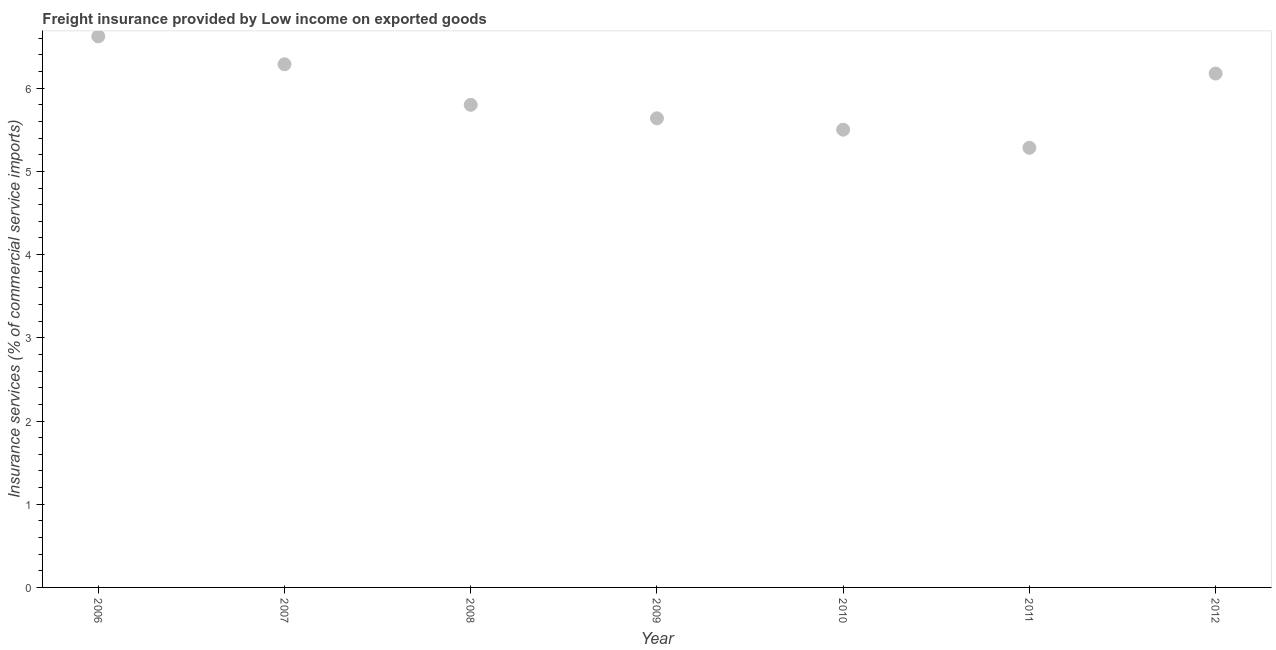What is the freight insurance in 2007?
Your answer should be compact. 6.29. Across all years, what is the maximum freight insurance?
Offer a very short reply. 6.62. Across all years, what is the minimum freight insurance?
Ensure brevity in your answer.  5.28. In which year was the freight insurance maximum?
Provide a succinct answer. 2006. In which year was the freight insurance minimum?
Your response must be concise. 2011. What is the sum of the freight insurance?
Your answer should be very brief. 41.31. What is the difference between the freight insurance in 2007 and 2012?
Give a very brief answer. 0.11. What is the average freight insurance per year?
Ensure brevity in your answer.  5.9. What is the median freight insurance?
Offer a very short reply. 5.8. In how many years, is the freight insurance greater than 5.4 %?
Your response must be concise. 6. Do a majority of the years between 2006 and 2007 (inclusive) have freight insurance greater than 2.8 %?
Provide a short and direct response. Yes. What is the ratio of the freight insurance in 2009 to that in 2011?
Offer a very short reply. 1.07. Is the freight insurance in 2006 less than that in 2012?
Offer a terse response. No. What is the difference between the highest and the second highest freight insurance?
Offer a terse response. 0.33. What is the difference between the highest and the lowest freight insurance?
Provide a succinct answer. 1.34. In how many years, is the freight insurance greater than the average freight insurance taken over all years?
Offer a terse response. 3. How many dotlines are there?
Your answer should be very brief. 1. What is the difference between two consecutive major ticks on the Y-axis?
Make the answer very short. 1. Are the values on the major ticks of Y-axis written in scientific E-notation?
Your response must be concise. No. Does the graph contain any zero values?
Give a very brief answer. No. What is the title of the graph?
Offer a very short reply. Freight insurance provided by Low income on exported goods . What is the label or title of the X-axis?
Give a very brief answer. Year. What is the label or title of the Y-axis?
Your response must be concise. Insurance services (% of commercial service imports). What is the Insurance services (% of commercial service imports) in 2006?
Give a very brief answer. 6.62. What is the Insurance services (% of commercial service imports) in 2007?
Ensure brevity in your answer.  6.29. What is the Insurance services (% of commercial service imports) in 2008?
Offer a terse response. 5.8. What is the Insurance services (% of commercial service imports) in 2009?
Offer a very short reply. 5.64. What is the Insurance services (% of commercial service imports) in 2010?
Your response must be concise. 5.5. What is the Insurance services (% of commercial service imports) in 2011?
Your answer should be very brief. 5.28. What is the Insurance services (% of commercial service imports) in 2012?
Keep it short and to the point. 6.18. What is the difference between the Insurance services (% of commercial service imports) in 2006 and 2007?
Offer a terse response. 0.33. What is the difference between the Insurance services (% of commercial service imports) in 2006 and 2008?
Your answer should be very brief. 0.82. What is the difference between the Insurance services (% of commercial service imports) in 2006 and 2009?
Your answer should be very brief. 0.98. What is the difference between the Insurance services (% of commercial service imports) in 2006 and 2010?
Offer a very short reply. 1.12. What is the difference between the Insurance services (% of commercial service imports) in 2006 and 2011?
Provide a short and direct response. 1.34. What is the difference between the Insurance services (% of commercial service imports) in 2006 and 2012?
Provide a succinct answer. 0.45. What is the difference between the Insurance services (% of commercial service imports) in 2007 and 2008?
Keep it short and to the point. 0.49. What is the difference between the Insurance services (% of commercial service imports) in 2007 and 2009?
Provide a short and direct response. 0.65. What is the difference between the Insurance services (% of commercial service imports) in 2007 and 2010?
Offer a terse response. 0.79. What is the difference between the Insurance services (% of commercial service imports) in 2007 and 2011?
Offer a terse response. 1. What is the difference between the Insurance services (% of commercial service imports) in 2007 and 2012?
Your answer should be very brief. 0.11. What is the difference between the Insurance services (% of commercial service imports) in 2008 and 2009?
Offer a terse response. 0.16. What is the difference between the Insurance services (% of commercial service imports) in 2008 and 2010?
Make the answer very short. 0.3. What is the difference between the Insurance services (% of commercial service imports) in 2008 and 2011?
Your response must be concise. 0.52. What is the difference between the Insurance services (% of commercial service imports) in 2008 and 2012?
Make the answer very short. -0.38. What is the difference between the Insurance services (% of commercial service imports) in 2009 and 2010?
Ensure brevity in your answer.  0.14. What is the difference between the Insurance services (% of commercial service imports) in 2009 and 2011?
Make the answer very short. 0.35. What is the difference between the Insurance services (% of commercial service imports) in 2009 and 2012?
Ensure brevity in your answer.  -0.54. What is the difference between the Insurance services (% of commercial service imports) in 2010 and 2011?
Offer a terse response. 0.22. What is the difference between the Insurance services (% of commercial service imports) in 2010 and 2012?
Your answer should be compact. -0.67. What is the difference between the Insurance services (% of commercial service imports) in 2011 and 2012?
Provide a short and direct response. -0.89. What is the ratio of the Insurance services (% of commercial service imports) in 2006 to that in 2007?
Keep it short and to the point. 1.05. What is the ratio of the Insurance services (% of commercial service imports) in 2006 to that in 2008?
Offer a very short reply. 1.14. What is the ratio of the Insurance services (% of commercial service imports) in 2006 to that in 2009?
Offer a terse response. 1.18. What is the ratio of the Insurance services (% of commercial service imports) in 2006 to that in 2010?
Make the answer very short. 1.2. What is the ratio of the Insurance services (% of commercial service imports) in 2006 to that in 2011?
Make the answer very short. 1.25. What is the ratio of the Insurance services (% of commercial service imports) in 2006 to that in 2012?
Your response must be concise. 1.07. What is the ratio of the Insurance services (% of commercial service imports) in 2007 to that in 2008?
Provide a succinct answer. 1.08. What is the ratio of the Insurance services (% of commercial service imports) in 2007 to that in 2009?
Ensure brevity in your answer.  1.11. What is the ratio of the Insurance services (% of commercial service imports) in 2007 to that in 2010?
Ensure brevity in your answer.  1.14. What is the ratio of the Insurance services (% of commercial service imports) in 2007 to that in 2011?
Offer a terse response. 1.19. What is the ratio of the Insurance services (% of commercial service imports) in 2007 to that in 2012?
Your answer should be very brief. 1.02. What is the ratio of the Insurance services (% of commercial service imports) in 2008 to that in 2010?
Make the answer very short. 1.05. What is the ratio of the Insurance services (% of commercial service imports) in 2008 to that in 2011?
Make the answer very short. 1.1. What is the ratio of the Insurance services (% of commercial service imports) in 2008 to that in 2012?
Provide a short and direct response. 0.94. What is the ratio of the Insurance services (% of commercial service imports) in 2009 to that in 2011?
Make the answer very short. 1.07. What is the ratio of the Insurance services (% of commercial service imports) in 2010 to that in 2011?
Make the answer very short. 1.04. What is the ratio of the Insurance services (% of commercial service imports) in 2010 to that in 2012?
Your response must be concise. 0.89. What is the ratio of the Insurance services (% of commercial service imports) in 2011 to that in 2012?
Make the answer very short. 0.86. 